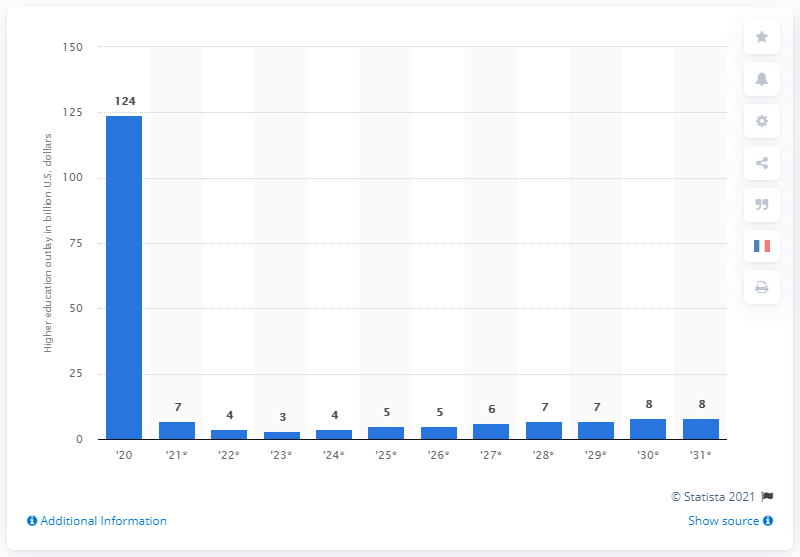Indicate a few pertinent items in this graphic. In 2020, the mandatory outlays for higher education in the United States amounted to approximately 124. The estimated amount of mandatory outlays for higher education in the United States in 2031 is projected to be $124. 